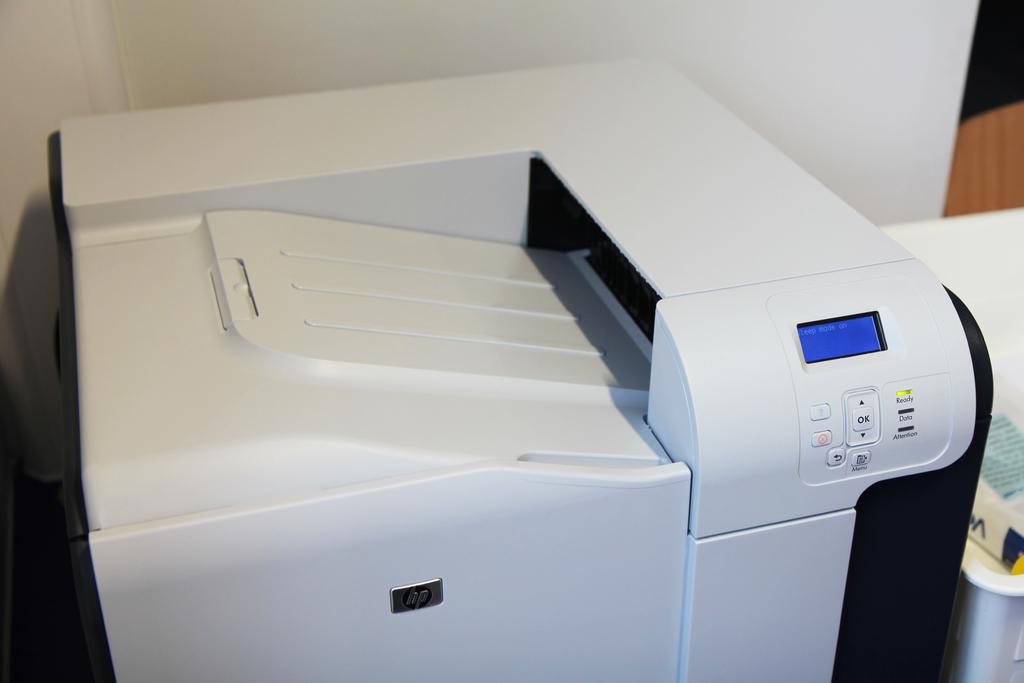What does the largest button say?
Offer a terse response. Ok. 